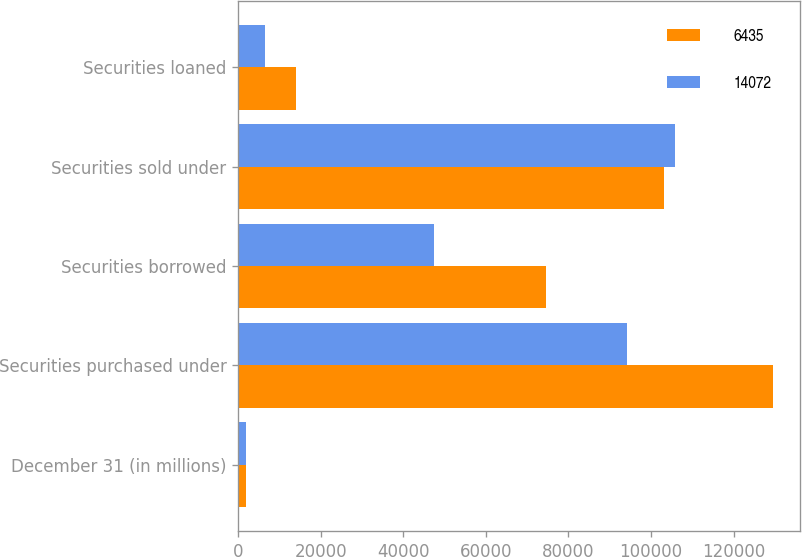Convert chart. <chart><loc_0><loc_0><loc_500><loc_500><stacked_bar_chart><ecel><fcel>December 31 (in millions)<fcel>Securities purchased under<fcel>Securities borrowed<fcel>Securities sold under<fcel>Securities loaned<nl><fcel>6435<fcel>2005<fcel>129570<fcel>74604<fcel>103052<fcel>14072<nl><fcel>14072<fcel>2004<fcel>94076<fcel>47428<fcel>105912<fcel>6435<nl></chart> 